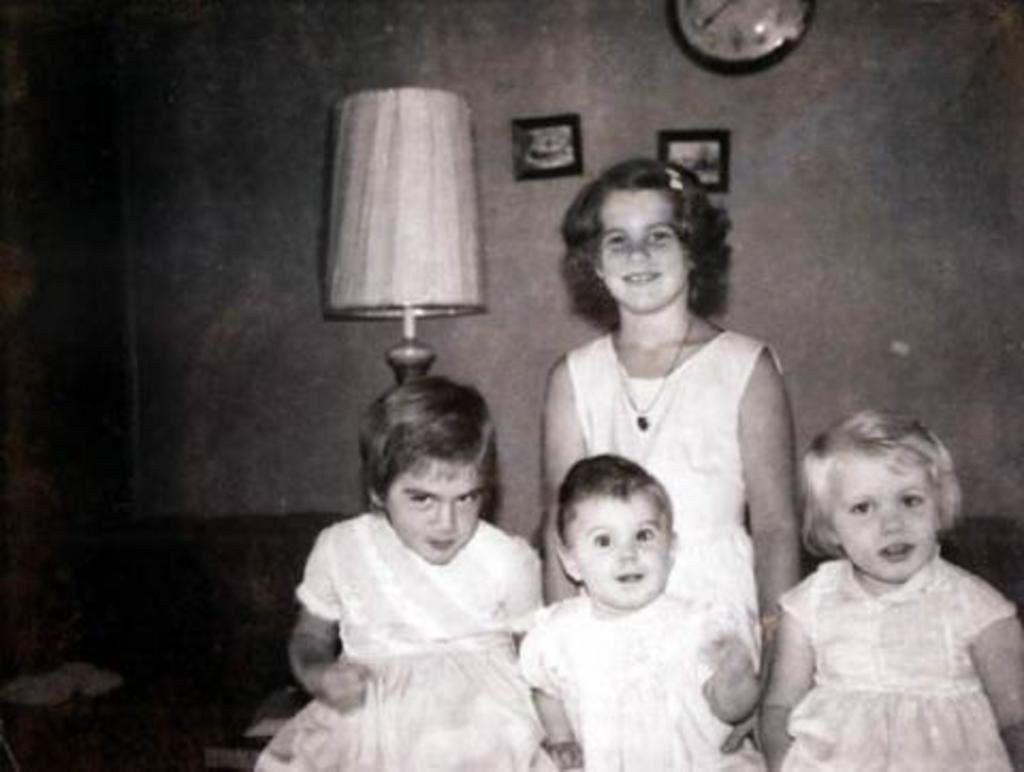How many children are present in the image? There are four children in the image. What is located behind the children? There is a lamp behind the children. What can be seen on the wall in the image? There are photo frames and a clock on the wall. What is on the left side of the image? There are objects on the left side of the image. How does the rake help the children in the image? There is no rake present in the image, so it cannot help the children. 